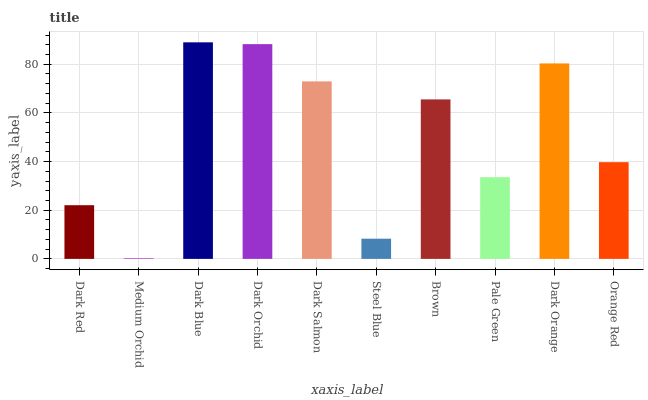Is Dark Blue the minimum?
Answer yes or no. No. Is Medium Orchid the maximum?
Answer yes or no. No. Is Dark Blue greater than Medium Orchid?
Answer yes or no. Yes. Is Medium Orchid less than Dark Blue?
Answer yes or no. Yes. Is Medium Orchid greater than Dark Blue?
Answer yes or no. No. Is Dark Blue less than Medium Orchid?
Answer yes or no. No. Is Brown the high median?
Answer yes or no. Yes. Is Orange Red the low median?
Answer yes or no. Yes. Is Dark Orange the high median?
Answer yes or no. No. Is Dark Orchid the low median?
Answer yes or no. No. 